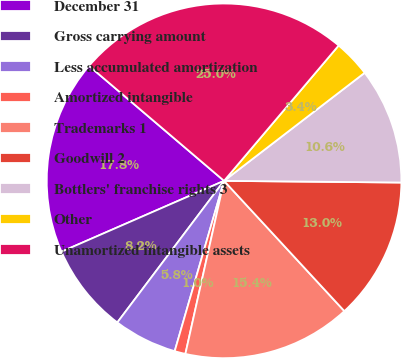Convert chart. <chart><loc_0><loc_0><loc_500><loc_500><pie_chart><fcel>December 31<fcel>Gross carrying amount<fcel>Less accumulated amortization<fcel>Amortized intangible<fcel>Trademarks 1<fcel>Goodwill 2<fcel>Bottlers' franchise rights 3<fcel>Other<fcel>Unamortized intangible assets<nl><fcel>17.77%<fcel>8.18%<fcel>5.79%<fcel>0.99%<fcel>15.37%<fcel>12.98%<fcel>10.58%<fcel>3.39%<fcel>24.96%<nl></chart> 